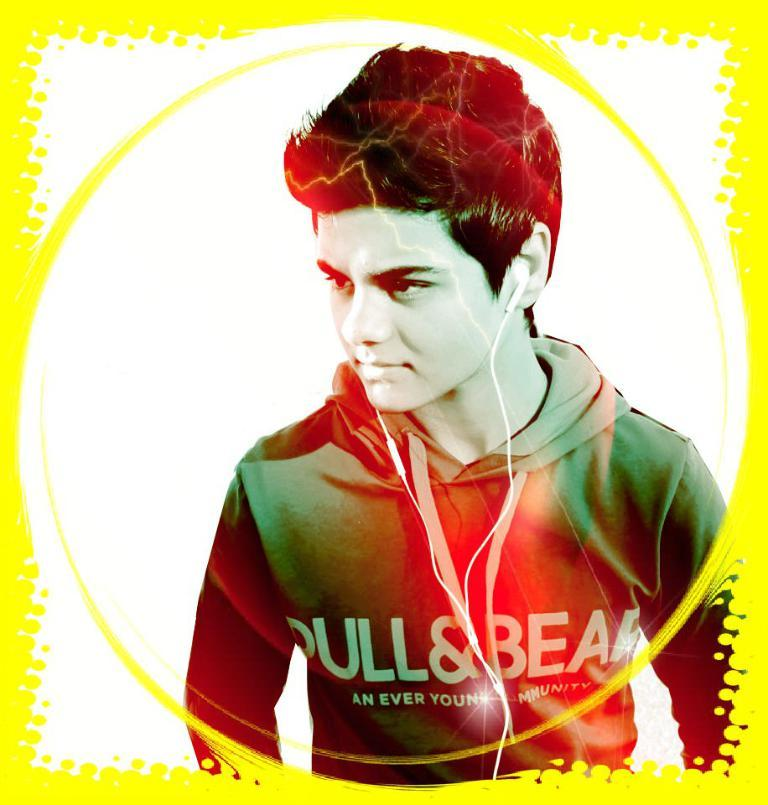<image>
Describe the image concisely. A boy wearing a sweatshirt that says Bull & Bear. 